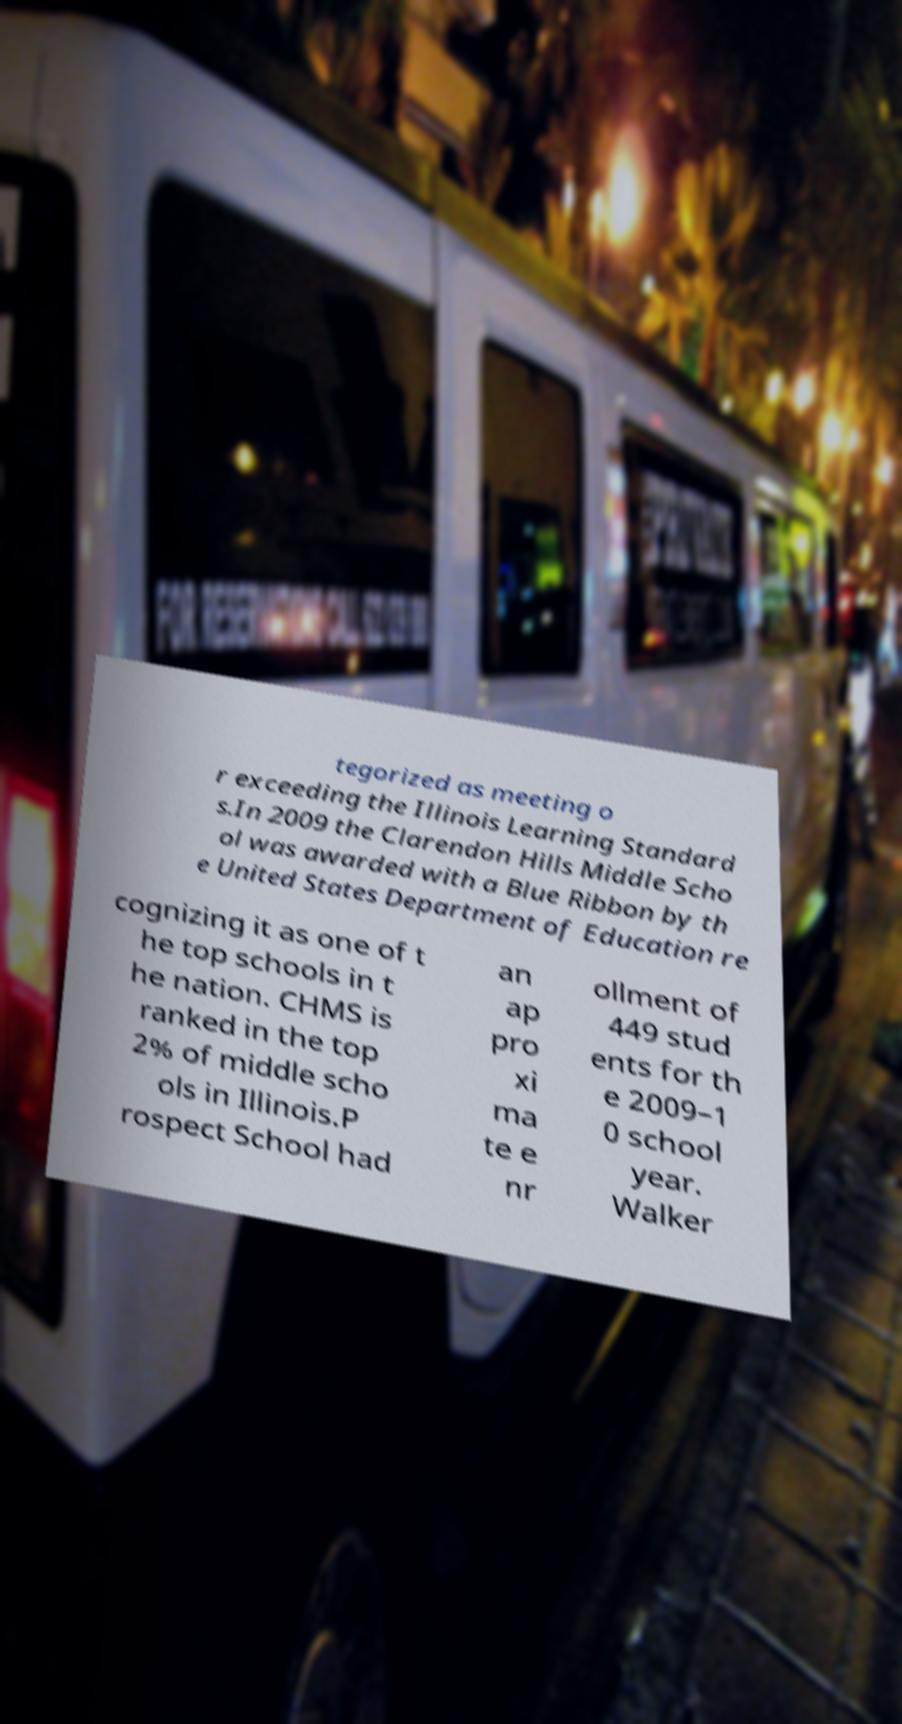Please read and relay the text visible in this image. What does it say? tegorized as meeting o r exceeding the Illinois Learning Standard s.In 2009 the Clarendon Hills Middle Scho ol was awarded with a Blue Ribbon by th e United States Department of Education re cognizing it as one of t he top schools in t he nation. CHMS is ranked in the top 2% of middle scho ols in Illinois.P rospect School had an ap pro xi ma te e nr ollment of 449 stud ents for th e 2009–1 0 school year. Walker 